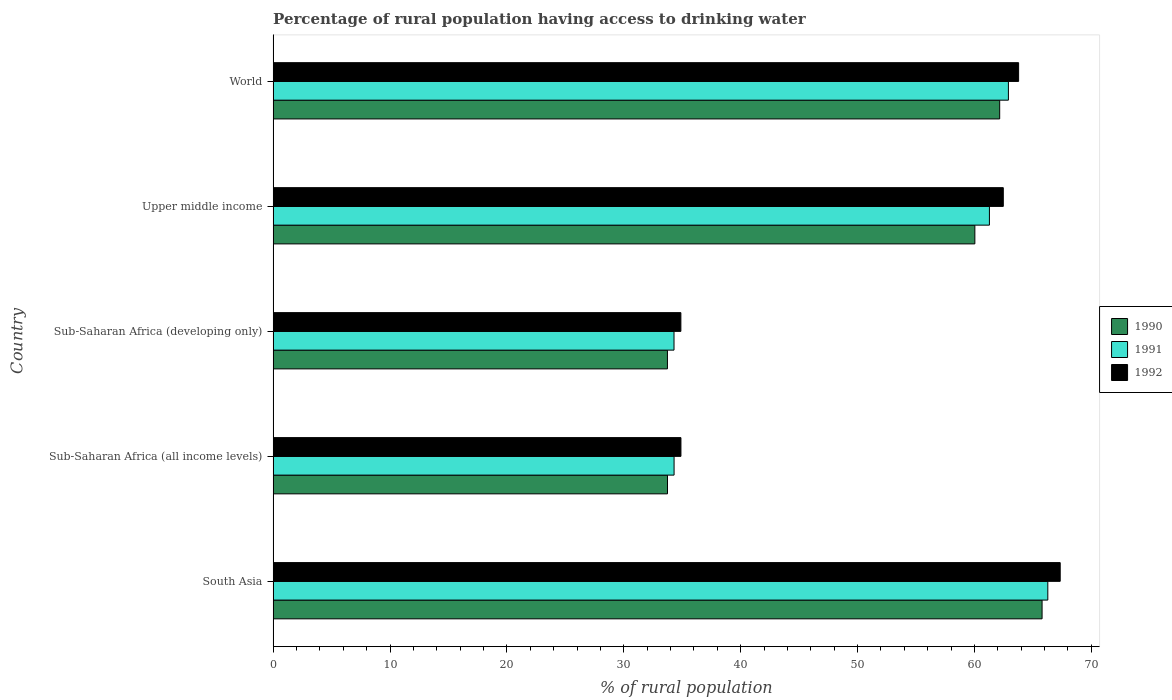Are the number of bars per tick equal to the number of legend labels?
Ensure brevity in your answer.  Yes. What is the label of the 2nd group of bars from the top?
Your answer should be very brief. Upper middle income. What is the percentage of rural population having access to drinking water in 1991 in World?
Provide a short and direct response. 62.91. Across all countries, what is the maximum percentage of rural population having access to drinking water in 1992?
Ensure brevity in your answer.  67.34. Across all countries, what is the minimum percentage of rural population having access to drinking water in 1992?
Offer a very short reply. 34.88. In which country was the percentage of rural population having access to drinking water in 1990 minimum?
Keep it short and to the point. Sub-Saharan Africa (developing only). What is the total percentage of rural population having access to drinking water in 1991 in the graph?
Keep it short and to the point. 259.06. What is the difference between the percentage of rural population having access to drinking water in 1991 in South Asia and that in World?
Offer a terse response. 3.37. What is the difference between the percentage of rural population having access to drinking water in 1991 in Upper middle income and the percentage of rural population having access to drinking water in 1990 in South Asia?
Provide a short and direct response. -4.51. What is the average percentage of rural population having access to drinking water in 1991 per country?
Your response must be concise. 51.81. What is the difference between the percentage of rural population having access to drinking water in 1992 and percentage of rural population having access to drinking water in 1991 in South Asia?
Provide a short and direct response. 1.06. In how many countries, is the percentage of rural population having access to drinking water in 1991 greater than 48 %?
Your answer should be very brief. 3. What is the ratio of the percentage of rural population having access to drinking water in 1991 in Sub-Saharan Africa (developing only) to that in Upper middle income?
Offer a very short reply. 0.56. What is the difference between the highest and the second highest percentage of rural population having access to drinking water in 1992?
Ensure brevity in your answer.  3.56. What is the difference between the highest and the lowest percentage of rural population having access to drinking water in 1990?
Give a very brief answer. 32.05. In how many countries, is the percentage of rural population having access to drinking water in 1990 greater than the average percentage of rural population having access to drinking water in 1990 taken over all countries?
Make the answer very short. 3. Is the sum of the percentage of rural population having access to drinking water in 1990 in Sub-Saharan Africa (all income levels) and Sub-Saharan Africa (developing only) greater than the maximum percentage of rural population having access to drinking water in 1992 across all countries?
Ensure brevity in your answer.  Yes. What does the 2nd bar from the top in Sub-Saharan Africa (developing only) represents?
Make the answer very short. 1991. What does the 3rd bar from the bottom in South Asia represents?
Offer a terse response. 1992. Is it the case that in every country, the sum of the percentage of rural population having access to drinking water in 1991 and percentage of rural population having access to drinking water in 1992 is greater than the percentage of rural population having access to drinking water in 1990?
Keep it short and to the point. Yes. How many bars are there?
Offer a very short reply. 15. How many countries are there in the graph?
Provide a short and direct response. 5. What is the difference between two consecutive major ticks on the X-axis?
Ensure brevity in your answer.  10. Does the graph contain any zero values?
Provide a succinct answer. No. How are the legend labels stacked?
Keep it short and to the point. Vertical. What is the title of the graph?
Your answer should be compact. Percentage of rural population having access to drinking water. What is the label or title of the X-axis?
Give a very brief answer. % of rural population. What is the label or title of the Y-axis?
Ensure brevity in your answer.  Country. What is the % of rural population in 1990 in South Asia?
Provide a succinct answer. 65.79. What is the % of rural population of 1991 in South Asia?
Provide a short and direct response. 66.28. What is the % of rural population in 1992 in South Asia?
Offer a very short reply. 67.34. What is the % of rural population in 1990 in Sub-Saharan Africa (all income levels)?
Your response must be concise. 33.74. What is the % of rural population of 1991 in Sub-Saharan Africa (all income levels)?
Keep it short and to the point. 34.3. What is the % of rural population in 1992 in Sub-Saharan Africa (all income levels)?
Offer a very short reply. 34.89. What is the % of rural population in 1990 in Sub-Saharan Africa (developing only)?
Give a very brief answer. 33.73. What is the % of rural population of 1991 in Sub-Saharan Africa (developing only)?
Offer a very short reply. 34.3. What is the % of rural population in 1992 in Sub-Saharan Africa (developing only)?
Keep it short and to the point. 34.88. What is the % of rural population in 1990 in Upper middle income?
Provide a succinct answer. 60.03. What is the % of rural population of 1991 in Upper middle income?
Provide a short and direct response. 61.28. What is the % of rural population in 1992 in Upper middle income?
Provide a short and direct response. 62.47. What is the % of rural population in 1990 in World?
Your response must be concise. 62.16. What is the % of rural population of 1991 in World?
Your answer should be compact. 62.91. What is the % of rural population of 1992 in World?
Keep it short and to the point. 63.78. Across all countries, what is the maximum % of rural population in 1990?
Your answer should be very brief. 65.79. Across all countries, what is the maximum % of rural population in 1991?
Provide a short and direct response. 66.28. Across all countries, what is the maximum % of rural population of 1992?
Make the answer very short. 67.34. Across all countries, what is the minimum % of rural population in 1990?
Make the answer very short. 33.73. Across all countries, what is the minimum % of rural population of 1991?
Keep it short and to the point. 34.3. Across all countries, what is the minimum % of rural population in 1992?
Your answer should be very brief. 34.88. What is the total % of rural population of 1990 in the graph?
Provide a succinct answer. 255.45. What is the total % of rural population in 1991 in the graph?
Make the answer very short. 259.06. What is the total % of rural population of 1992 in the graph?
Offer a terse response. 263.35. What is the difference between the % of rural population in 1990 in South Asia and that in Sub-Saharan Africa (all income levels)?
Offer a very short reply. 32.05. What is the difference between the % of rural population of 1991 in South Asia and that in Sub-Saharan Africa (all income levels)?
Keep it short and to the point. 31.97. What is the difference between the % of rural population of 1992 in South Asia and that in Sub-Saharan Africa (all income levels)?
Offer a terse response. 32.45. What is the difference between the % of rural population of 1990 in South Asia and that in Sub-Saharan Africa (developing only)?
Give a very brief answer. 32.05. What is the difference between the % of rural population of 1991 in South Asia and that in Sub-Saharan Africa (developing only)?
Offer a terse response. 31.98. What is the difference between the % of rural population in 1992 in South Asia and that in Sub-Saharan Africa (developing only)?
Make the answer very short. 32.45. What is the difference between the % of rural population in 1990 in South Asia and that in Upper middle income?
Your answer should be compact. 5.75. What is the difference between the % of rural population in 1991 in South Asia and that in Upper middle income?
Ensure brevity in your answer.  5. What is the difference between the % of rural population of 1992 in South Asia and that in Upper middle income?
Your answer should be very brief. 4.87. What is the difference between the % of rural population of 1990 in South Asia and that in World?
Your response must be concise. 3.63. What is the difference between the % of rural population of 1991 in South Asia and that in World?
Your answer should be very brief. 3.37. What is the difference between the % of rural population in 1992 in South Asia and that in World?
Offer a very short reply. 3.56. What is the difference between the % of rural population in 1990 in Sub-Saharan Africa (all income levels) and that in Sub-Saharan Africa (developing only)?
Make the answer very short. 0.01. What is the difference between the % of rural population of 1991 in Sub-Saharan Africa (all income levels) and that in Sub-Saharan Africa (developing only)?
Your answer should be compact. 0.01. What is the difference between the % of rural population of 1992 in Sub-Saharan Africa (all income levels) and that in Sub-Saharan Africa (developing only)?
Make the answer very short. 0.01. What is the difference between the % of rural population of 1990 in Sub-Saharan Africa (all income levels) and that in Upper middle income?
Offer a terse response. -26.29. What is the difference between the % of rural population in 1991 in Sub-Saharan Africa (all income levels) and that in Upper middle income?
Offer a very short reply. -26.98. What is the difference between the % of rural population in 1992 in Sub-Saharan Africa (all income levels) and that in Upper middle income?
Give a very brief answer. -27.58. What is the difference between the % of rural population in 1990 in Sub-Saharan Africa (all income levels) and that in World?
Provide a short and direct response. -28.42. What is the difference between the % of rural population in 1991 in Sub-Saharan Africa (all income levels) and that in World?
Ensure brevity in your answer.  -28.6. What is the difference between the % of rural population of 1992 in Sub-Saharan Africa (all income levels) and that in World?
Your response must be concise. -28.89. What is the difference between the % of rural population in 1990 in Sub-Saharan Africa (developing only) and that in Upper middle income?
Your response must be concise. -26.3. What is the difference between the % of rural population in 1991 in Sub-Saharan Africa (developing only) and that in Upper middle income?
Your answer should be very brief. -26.98. What is the difference between the % of rural population of 1992 in Sub-Saharan Africa (developing only) and that in Upper middle income?
Offer a very short reply. -27.58. What is the difference between the % of rural population in 1990 in Sub-Saharan Africa (developing only) and that in World?
Offer a very short reply. -28.42. What is the difference between the % of rural population in 1991 in Sub-Saharan Africa (developing only) and that in World?
Your response must be concise. -28.61. What is the difference between the % of rural population in 1992 in Sub-Saharan Africa (developing only) and that in World?
Your answer should be compact. -28.89. What is the difference between the % of rural population in 1990 in Upper middle income and that in World?
Your answer should be very brief. -2.12. What is the difference between the % of rural population in 1991 in Upper middle income and that in World?
Offer a very short reply. -1.62. What is the difference between the % of rural population of 1992 in Upper middle income and that in World?
Your response must be concise. -1.31. What is the difference between the % of rural population in 1990 in South Asia and the % of rural population in 1991 in Sub-Saharan Africa (all income levels)?
Your answer should be very brief. 31.48. What is the difference between the % of rural population in 1990 in South Asia and the % of rural population in 1992 in Sub-Saharan Africa (all income levels)?
Provide a short and direct response. 30.9. What is the difference between the % of rural population in 1991 in South Asia and the % of rural population in 1992 in Sub-Saharan Africa (all income levels)?
Your answer should be compact. 31.39. What is the difference between the % of rural population of 1990 in South Asia and the % of rural population of 1991 in Sub-Saharan Africa (developing only)?
Your answer should be compact. 31.49. What is the difference between the % of rural population in 1990 in South Asia and the % of rural population in 1992 in Sub-Saharan Africa (developing only)?
Your response must be concise. 30.9. What is the difference between the % of rural population in 1991 in South Asia and the % of rural population in 1992 in Sub-Saharan Africa (developing only)?
Keep it short and to the point. 31.39. What is the difference between the % of rural population of 1990 in South Asia and the % of rural population of 1991 in Upper middle income?
Your answer should be very brief. 4.51. What is the difference between the % of rural population in 1990 in South Asia and the % of rural population in 1992 in Upper middle income?
Offer a very short reply. 3.32. What is the difference between the % of rural population of 1991 in South Asia and the % of rural population of 1992 in Upper middle income?
Make the answer very short. 3.81. What is the difference between the % of rural population in 1990 in South Asia and the % of rural population in 1991 in World?
Offer a terse response. 2.88. What is the difference between the % of rural population of 1990 in South Asia and the % of rural population of 1992 in World?
Offer a terse response. 2.01. What is the difference between the % of rural population in 1991 in South Asia and the % of rural population in 1992 in World?
Give a very brief answer. 2.5. What is the difference between the % of rural population in 1990 in Sub-Saharan Africa (all income levels) and the % of rural population in 1991 in Sub-Saharan Africa (developing only)?
Keep it short and to the point. -0.56. What is the difference between the % of rural population of 1990 in Sub-Saharan Africa (all income levels) and the % of rural population of 1992 in Sub-Saharan Africa (developing only)?
Your answer should be very brief. -1.14. What is the difference between the % of rural population in 1991 in Sub-Saharan Africa (all income levels) and the % of rural population in 1992 in Sub-Saharan Africa (developing only)?
Offer a terse response. -0.58. What is the difference between the % of rural population in 1990 in Sub-Saharan Africa (all income levels) and the % of rural population in 1991 in Upper middle income?
Your answer should be very brief. -27.54. What is the difference between the % of rural population of 1990 in Sub-Saharan Africa (all income levels) and the % of rural population of 1992 in Upper middle income?
Keep it short and to the point. -28.73. What is the difference between the % of rural population of 1991 in Sub-Saharan Africa (all income levels) and the % of rural population of 1992 in Upper middle income?
Make the answer very short. -28.17. What is the difference between the % of rural population in 1990 in Sub-Saharan Africa (all income levels) and the % of rural population in 1991 in World?
Keep it short and to the point. -29.17. What is the difference between the % of rural population in 1990 in Sub-Saharan Africa (all income levels) and the % of rural population in 1992 in World?
Your answer should be very brief. -30.04. What is the difference between the % of rural population in 1991 in Sub-Saharan Africa (all income levels) and the % of rural population in 1992 in World?
Offer a very short reply. -29.47. What is the difference between the % of rural population in 1990 in Sub-Saharan Africa (developing only) and the % of rural population in 1991 in Upper middle income?
Give a very brief answer. -27.55. What is the difference between the % of rural population in 1990 in Sub-Saharan Africa (developing only) and the % of rural population in 1992 in Upper middle income?
Offer a terse response. -28.73. What is the difference between the % of rural population of 1991 in Sub-Saharan Africa (developing only) and the % of rural population of 1992 in Upper middle income?
Your answer should be compact. -28.17. What is the difference between the % of rural population of 1990 in Sub-Saharan Africa (developing only) and the % of rural population of 1991 in World?
Your answer should be compact. -29.17. What is the difference between the % of rural population in 1990 in Sub-Saharan Africa (developing only) and the % of rural population in 1992 in World?
Provide a succinct answer. -30.04. What is the difference between the % of rural population in 1991 in Sub-Saharan Africa (developing only) and the % of rural population in 1992 in World?
Your response must be concise. -29.48. What is the difference between the % of rural population in 1990 in Upper middle income and the % of rural population in 1991 in World?
Keep it short and to the point. -2.87. What is the difference between the % of rural population of 1990 in Upper middle income and the % of rural population of 1992 in World?
Provide a succinct answer. -3.74. What is the difference between the % of rural population of 1991 in Upper middle income and the % of rural population of 1992 in World?
Offer a terse response. -2.5. What is the average % of rural population of 1990 per country?
Offer a very short reply. 51.09. What is the average % of rural population of 1991 per country?
Give a very brief answer. 51.81. What is the average % of rural population in 1992 per country?
Provide a short and direct response. 52.67. What is the difference between the % of rural population in 1990 and % of rural population in 1991 in South Asia?
Provide a short and direct response. -0.49. What is the difference between the % of rural population of 1990 and % of rural population of 1992 in South Asia?
Provide a short and direct response. -1.55. What is the difference between the % of rural population in 1991 and % of rural population in 1992 in South Asia?
Provide a short and direct response. -1.06. What is the difference between the % of rural population of 1990 and % of rural population of 1991 in Sub-Saharan Africa (all income levels)?
Offer a very short reply. -0.56. What is the difference between the % of rural population of 1990 and % of rural population of 1992 in Sub-Saharan Africa (all income levels)?
Your answer should be very brief. -1.15. What is the difference between the % of rural population of 1991 and % of rural population of 1992 in Sub-Saharan Africa (all income levels)?
Give a very brief answer. -0.59. What is the difference between the % of rural population of 1990 and % of rural population of 1991 in Sub-Saharan Africa (developing only)?
Keep it short and to the point. -0.56. What is the difference between the % of rural population of 1990 and % of rural population of 1992 in Sub-Saharan Africa (developing only)?
Provide a succinct answer. -1.15. What is the difference between the % of rural population of 1991 and % of rural population of 1992 in Sub-Saharan Africa (developing only)?
Your answer should be very brief. -0.59. What is the difference between the % of rural population in 1990 and % of rural population in 1991 in Upper middle income?
Offer a very short reply. -1.25. What is the difference between the % of rural population of 1990 and % of rural population of 1992 in Upper middle income?
Ensure brevity in your answer.  -2.43. What is the difference between the % of rural population of 1991 and % of rural population of 1992 in Upper middle income?
Ensure brevity in your answer.  -1.19. What is the difference between the % of rural population in 1990 and % of rural population in 1991 in World?
Keep it short and to the point. -0.75. What is the difference between the % of rural population of 1990 and % of rural population of 1992 in World?
Give a very brief answer. -1.62. What is the difference between the % of rural population in 1991 and % of rural population in 1992 in World?
Ensure brevity in your answer.  -0.87. What is the ratio of the % of rural population in 1990 in South Asia to that in Sub-Saharan Africa (all income levels)?
Provide a short and direct response. 1.95. What is the ratio of the % of rural population in 1991 in South Asia to that in Sub-Saharan Africa (all income levels)?
Ensure brevity in your answer.  1.93. What is the ratio of the % of rural population in 1992 in South Asia to that in Sub-Saharan Africa (all income levels)?
Give a very brief answer. 1.93. What is the ratio of the % of rural population of 1990 in South Asia to that in Sub-Saharan Africa (developing only)?
Provide a succinct answer. 1.95. What is the ratio of the % of rural population in 1991 in South Asia to that in Sub-Saharan Africa (developing only)?
Your answer should be compact. 1.93. What is the ratio of the % of rural population of 1992 in South Asia to that in Sub-Saharan Africa (developing only)?
Your answer should be very brief. 1.93. What is the ratio of the % of rural population in 1990 in South Asia to that in Upper middle income?
Your answer should be very brief. 1.1. What is the ratio of the % of rural population in 1991 in South Asia to that in Upper middle income?
Offer a very short reply. 1.08. What is the ratio of the % of rural population in 1992 in South Asia to that in Upper middle income?
Offer a terse response. 1.08. What is the ratio of the % of rural population in 1990 in South Asia to that in World?
Your answer should be very brief. 1.06. What is the ratio of the % of rural population of 1991 in South Asia to that in World?
Keep it short and to the point. 1.05. What is the ratio of the % of rural population of 1992 in South Asia to that in World?
Make the answer very short. 1.06. What is the ratio of the % of rural population of 1990 in Sub-Saharan Africa (all income levels) to that in Sub-Saharan Africa (developing only)?
Give a very brief answer. 1. What is the ratio of the % of rural population of 1990 in Sub-Saharan Africa (all income levels) to that in Upper middle income?
Offer a very short reply. 0.56. What is the ratio of the % of rural population of 1991 in Sub-Saharan Africa (all income levels) to that in Upper middle income?
Make the answer very short. 0.56. What is the ratio of the % of rural population in 1992 in Sub-Saharan Africa (all income levels) to that in Upper middle income?
Ensure brevity in your answer.  0.56. What is the ratio of the % of rural population of 1990 in Sub-Saharan Africa (all income levels) to that in World?
Make the answer very short. 0.54. What is the ratio of the % of rural population of 1991 in Sub-Saharan Africa (all income levels) to that in World?
Your answer should be very brief. 0.55. What is the ratio of the % of rural population in 1992 in Sub-Saharan Africa (all income levels) to that in World?
Provide a short and direct response. 0.55. What is the ratio of the % of rural population of 1990 in Sub-Saharan Africa (developing only) to that in Upper middle income?
Make the answer very short. 0.56. What is the ratio of the % of rural population of 1991 in Sub-Saharan Africa (developing only) to that in Upper middle income?
Your response must be concise. 0.56. What is the ratio of the % of rural population in 1992 in Sub-Saharan Africa (developing only) to that in Upper middle income?
Keep it short and to the point. 0.56. What is the ratio of the % of rural population of 1990 in Sub-Saharan Africa (developing only) to that in World?
Your answer should be compact. 0.54. What is the ratio of the % of rural population in 1991 in Sub-Saharan Africa (developing only) to that in World?
Offer a terse response. 0.55. What is the ratio of the % of rural population of 1992 in Sub-Saharan Africa (developing only) to that in World?
Your answer should be very brief. 0.55. What is the ratio of the % of rural population of 1990 in Upper middle income to that in World?
Provide a succinct answer. 0.97. What is the ratio of the % of rural population in 1991 in Upper middle income to that in World?
Provide a succinct answer. 0.97. What is the ratio of the % of rural population of 1992 in Upper middle income to that in World?
Your answer should be compact. 0.98. What is the difference between the highest and the second highest % of rural population in 1990?
Offer a very short reply. 3.63. What is the difference between the highest and the second highest % of rural population of 1991?
Ensure brevity in your answer.  3.37. What is the difference between the highest and the second highest % of rural population of 1992?
Offer a terse response. 3.56. What is the difference between the highest and the lowest % of rural population in 1990?
Offer a terse response. 32.05. What is the difference between the highest and the lowest % of rural population in 1991?
Keep it short and to the point. 31.98. What is the difference between the highest and the lowest % of rural population in 1992?
Offer a terse response. 32.45. 